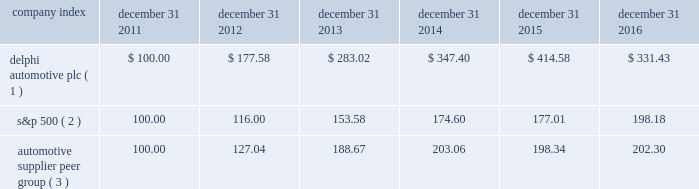Stock performance graph * $ 100 invested on december 31 , 2011 in our stock or in the relevant index , including reinvestment of dividends .
Fiscal year ended december 31 , 2016 .
( 1 ) delphi automotive plc ( 2 ) s&p 500 2013 standard & poor 2019s 500 total return index ( 3 ) automotive supplier peer group 2013 russell 3000 auto parts index , including american axle & manufacturing , borgwarner inc. , cooper tire & rubber company , dana inc. , delphi automotive plc , dorman products inc. , federal-mogul corp. , ford motor co. , general motors co. , gentex corp. , gentherm inc. , genuine parts co. , goodyear tire & rubber co. , johnson controls international plc , lear corp. , lkq corp. , meritor inc. , standard motor products inc. , stoneridge inc. , superior industries international , tenneco inc. , tesla motors inc. , tower international inc. , visteon corp. , and wabco holdings inc .
Company index december 31 , december 31 , december 31 , december 31 , december 31 , december 31 .
Dividends the company has declared and paid cash dividends of $ 0.25 and $ 0.29 per ordinary share in each quarter of 2015 and 2016 , respectively .
In addition , in january 2017 , the board of directors declared a regular quarterly cash dividend of $ 0.29 per ordinary share , payable on february 15 , 2017 to shareholders of record at the close of business on february 6 , 2017. .
What was the percentage return for the 5 year period ending december 31 2016 of delphi automotive plc? 
Computations: ((331.43 - 100) / 100)
Answer: 2.3143. 